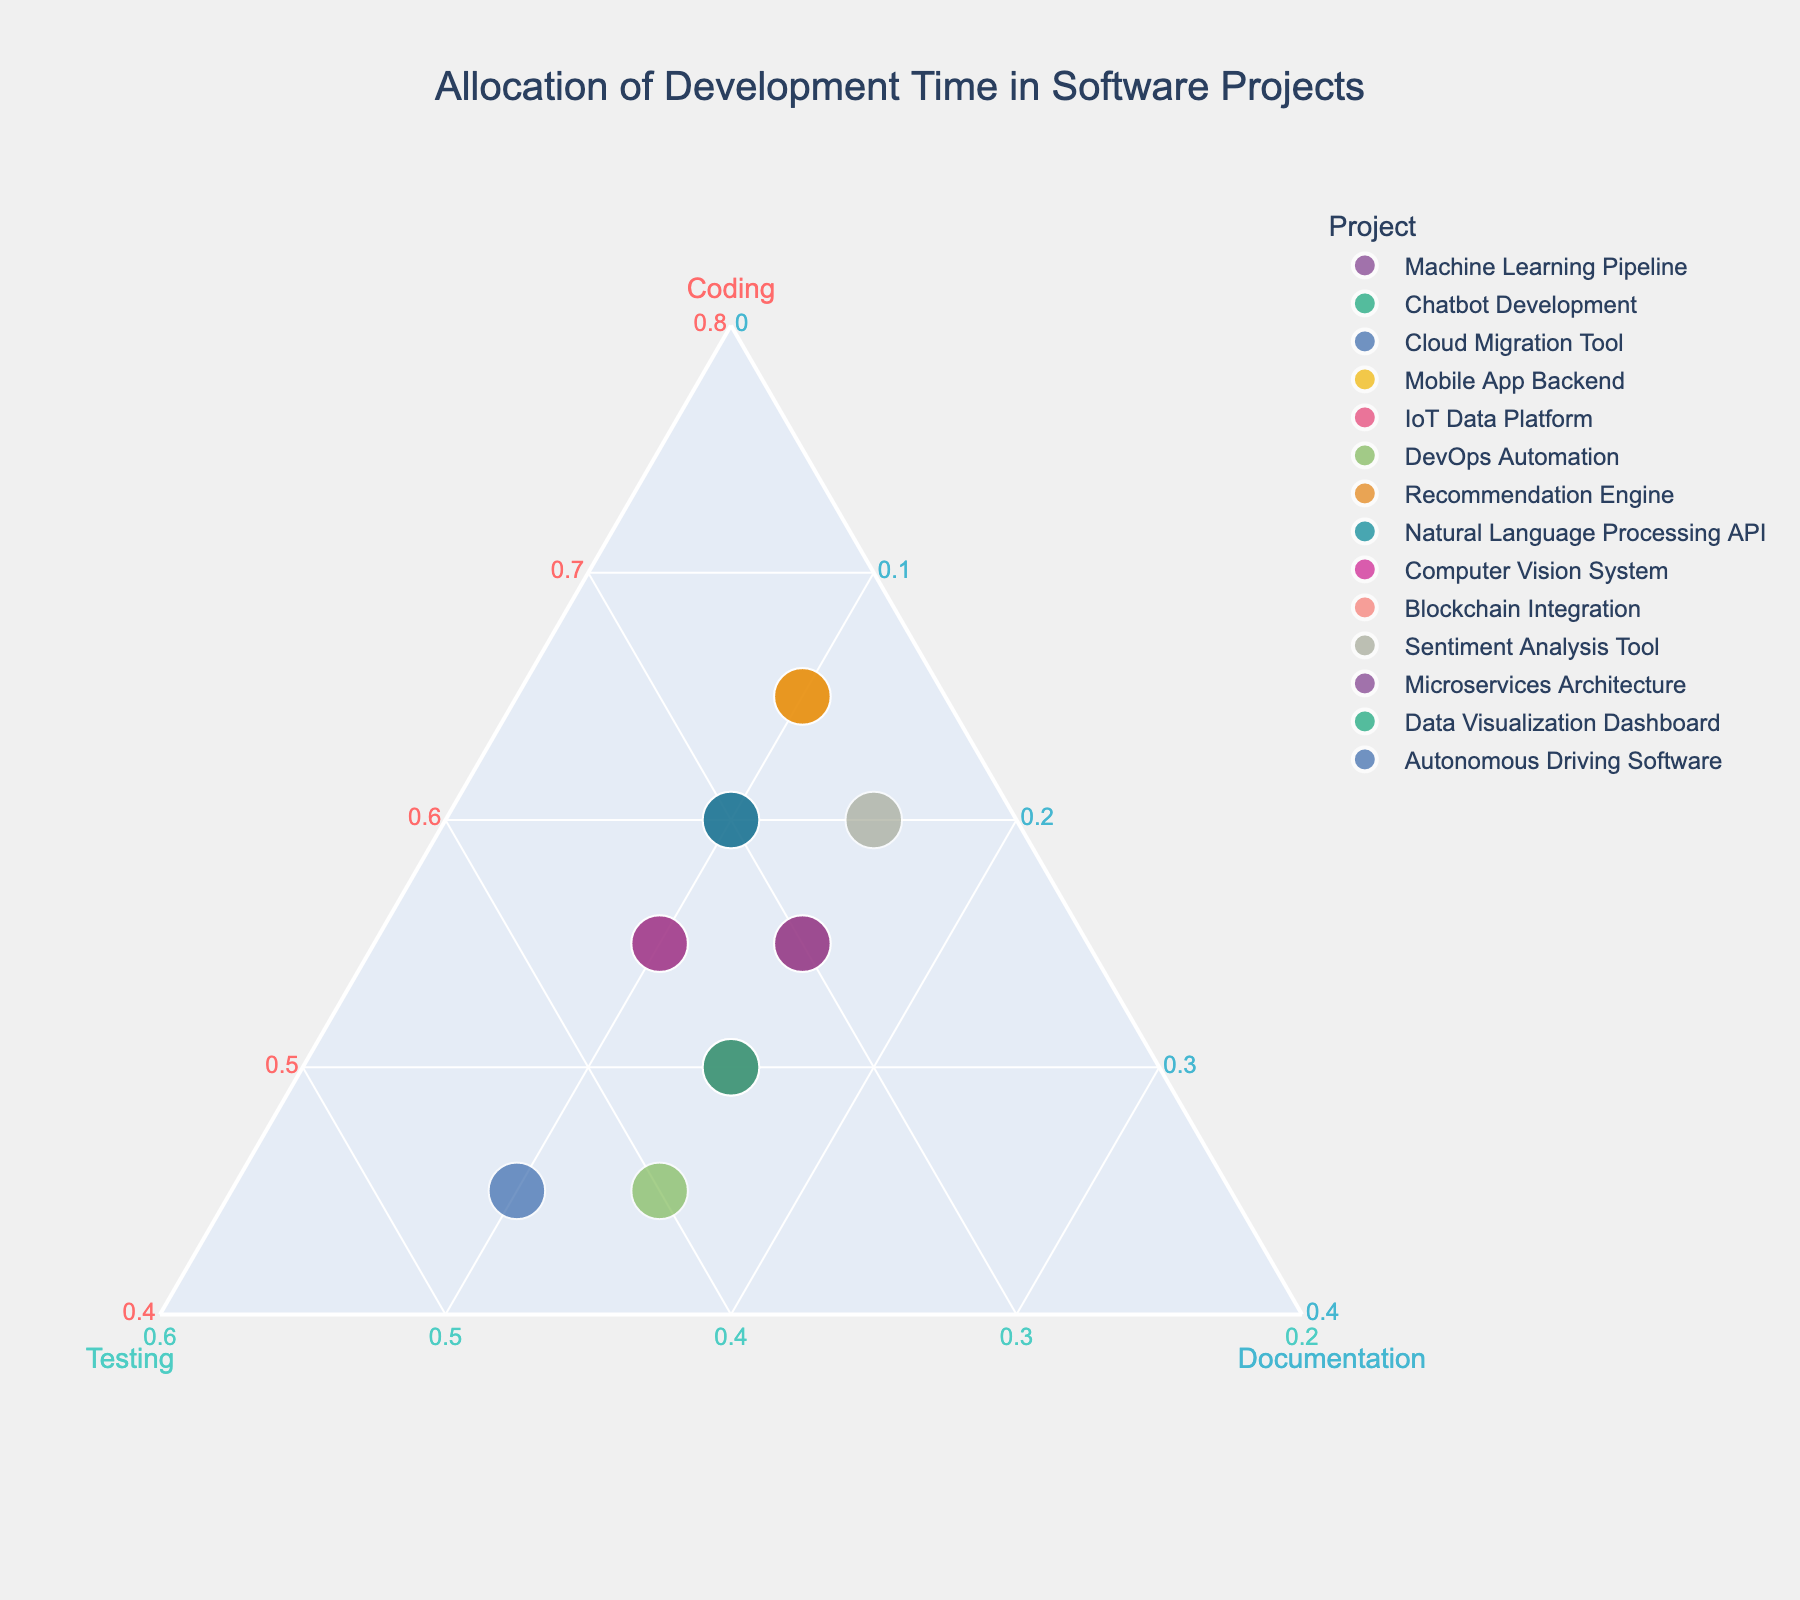How many projects are shown in the plot? Count the number of distinct points representing each project in the plot.
Answer: 14 Which project has the highest allocation for coding? Look for the point furthest along the `Coding` axis in the plot.
Answer: Mobile App Backend, Recommendation Engine Which project has allocated the least time for documentation? Find the point closest to the `Documentation` axis's origin in the plot.
Answer: Machine Learning Pipeline, Chatbot Development, Mobile App Backend, Recommendation Engine, Natural Language Processing API, Computer Vision System How many projects allocate exactly 15% of their time to documentation? Identify the points that are placed at the 15% mark along the `Documentation` axis.
Answer: 6 Which project allocates more time to testing: the Cloud Migration Tool or the Autonomous Driving Software? Compare the `Testing` percentage of both projects by checking their positions relative to the `Testing` axis.
Answer: Autonomous Driving Software Which two projects have the same allocation proportion across coding, testing, and documentation? Look for points that overlap or are very close on all three axes in the plot.
Answer: Machine Learning Pipeline, Natural Language Processing API What’s the difference in the coding allocation between DevOps Automation and Sentiment Analysis Tool? Subtract the coding percentage of the DevOps Automation from the coding percentage of the Sentiment Analysis Tool.
Answer: 15% Which project spends more time on testing: IoT Data Platform or Sentiment Analysis Tool? Compare the `Testing` percentage of both projects by looking at their positions along the `Testing` axis.
Answer: IoT Data Platform What’s the total allocation for testing in the projects DevOps Automation and Blockchain Integration combined? Add the `Testing` percentages of DevOps Automation and Blockchain Integration.
Answer: 75% If you average the documentation time across all projects, what value do you get? Calculate the mean percentage of the `Documentation` allocation among all projects by summing the values and dividing by the number of projects.
Answer: 12.9% 